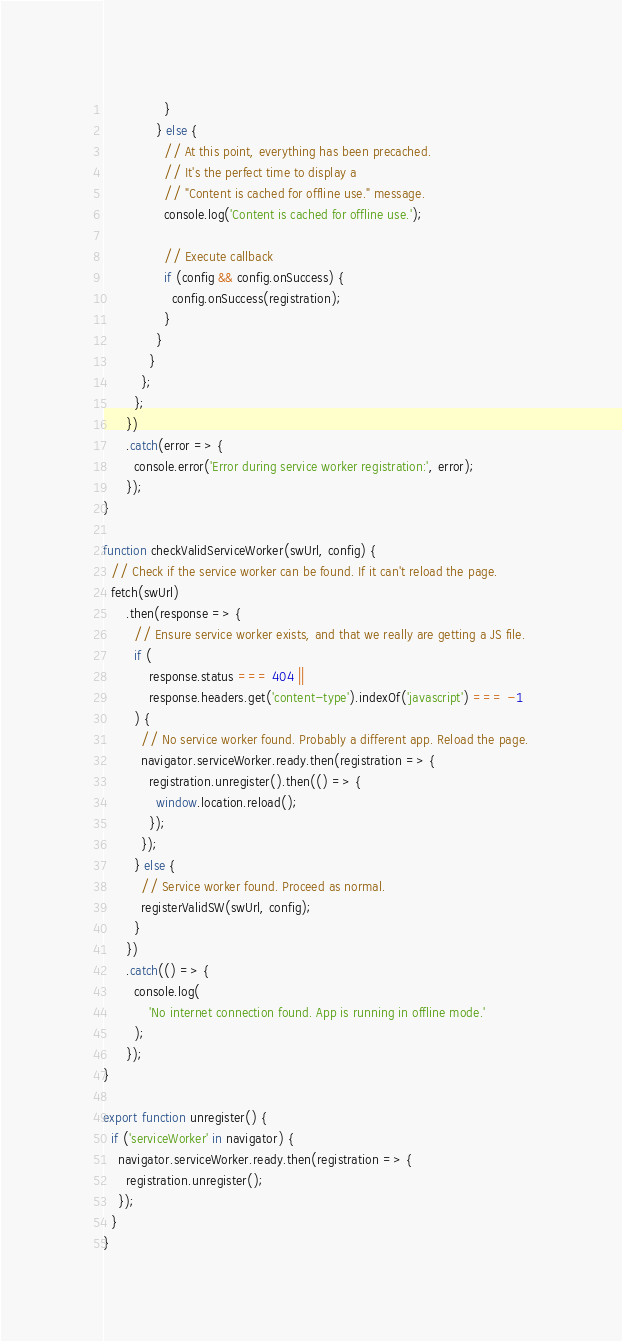<code> <loc_0><loc_0><loc_500><loc_500><_JavaScript_>                }
              } else {
                // At this point, everything has been precached.
                // It's the perfect time to display a
                // "Content is cached for offline use." message.
                console.log('Content is cached for offline use.');

                // Execute callback
                if (config && config.onSuccess) {
                  config.onSuccess(registration);
                }
              }
            }
          };
        };
      })
      .catch(error => {
        console.error('Error during service worker registration:', error);
      });
}

function checkValidServiceWorker(swUrl, config) {
  // Check if the service worker can be found. If it can't reload the page.
  fetch(swUrl)
      .then(response => {
        // Ensure service worker exists, and that we really are getting a JS file.
        if (
            response.status === 404 ||
            response.headers.get('content-type').indexOf('javascript') === -1
        ) {
          // No service worker found. Probably a different app. Reload the page.
          navigator.serviceWorker.ready.then(registration => {
            registration.unregister().then(() => {
              window.location.reload();
            });
          });
        } else {
          // Service worker found. Proceed as normal.
          registerValidSW(swUrl, config);
        }
      })
      .catch(() => {
        console.log(
            'No internet connection found. App is running in offline mode.'
        );
      });
}

export function unregister() {
  if ('serviceWorker' in navigator) {
    navigator.serviceWorker.ready.then(registration => {
      registration.unregister();
    });
  }
}</code> 